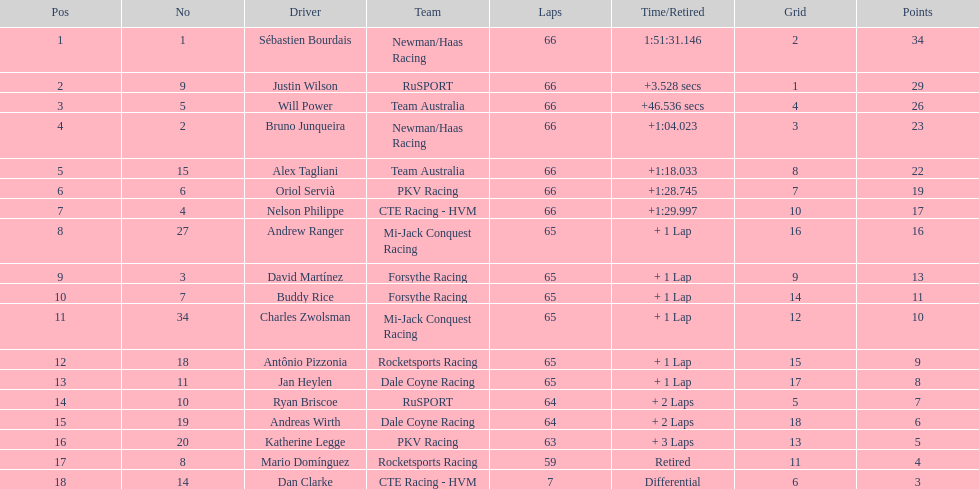Rice finished 10th. who finished next? Charles Zwolsman. 